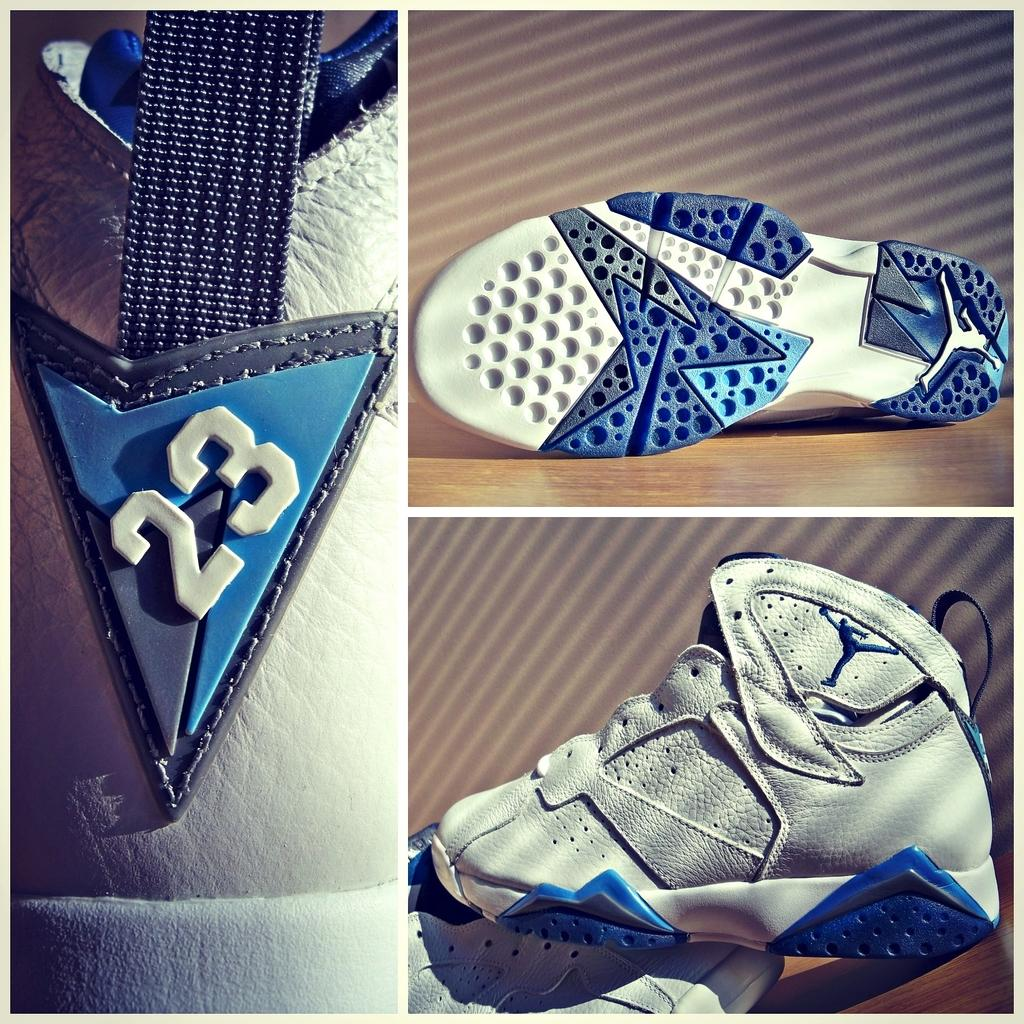What type of picture is in the image? There is a collage picture in the image. What is depicted in the collage picture? The collage picture contains a footwear. What colors are present in the footwear? The footwear is white, blue, and black in color. How many plants are growing in the footwear in the image? There are no plants present in the image, as it features a collage picture with a footwear. 